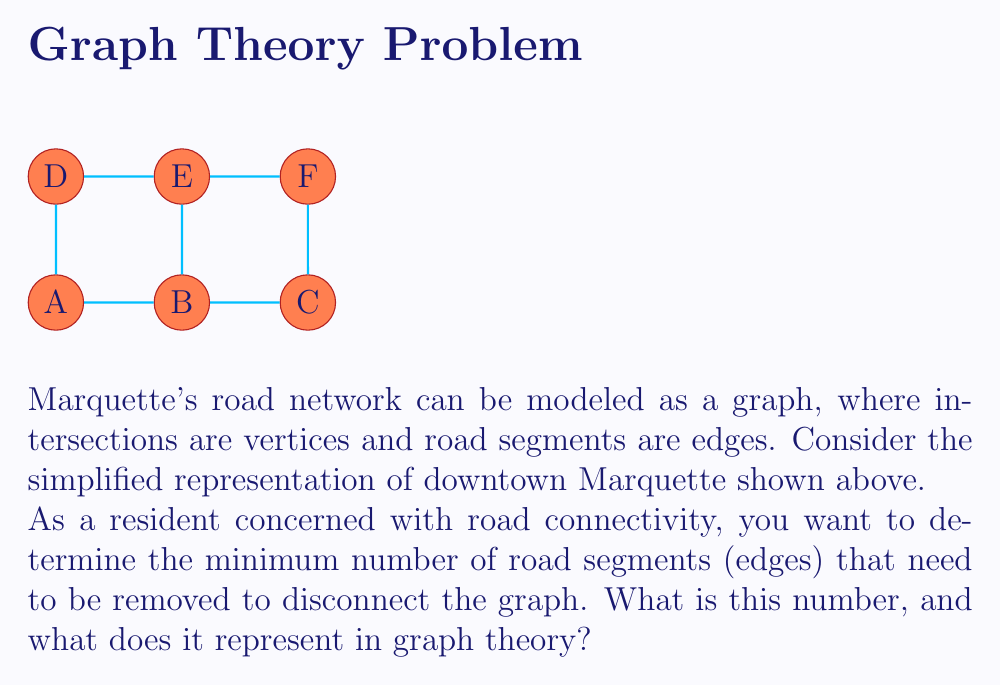Can you solve this math problem? To solve this problem, we need to understand the concept of edge connectivity in graph theory:

1. Edge connectivity is the minimum number of edges that need to be removed to disconnect a graph.

2. In graph theory, this is also known as the minimum cut of the graph.

3. To find the edge connectivity, we need to analyze all possible ways to disconnect the graph and find the minimum number of edges required.

4. Looking at the given graph:
   - It has 6 vertices (A, B, C, D, E, F) and 7 edges.
   - The graph forms a cycle with one internal edge (B-E).

5. To disconnect this graph:
   - Removing any single edge will not disconnect the graph due to the cycle structure.
   - Removing any two non-adjacent edges will disconnect the graph.

6. The minimum number of edges to remove is 2. For example:
   - Removing A-B and D-E would disconnect vertex A from the rest of the graph.
   - Removing B-C and E-F would disconnect vertices A, B, D, E from C and F.

7. In graph theory, this means:
   - The edge connectivity of the graph is 2.
   - The graph is 2-edge-connected.

This number represents the resilience of Marquette's road network to disconnection. It indicates that at least two road closures would be needed to completely cut off any part of the downtown area from the rest.
Answer: 2 (edge connectivity) 